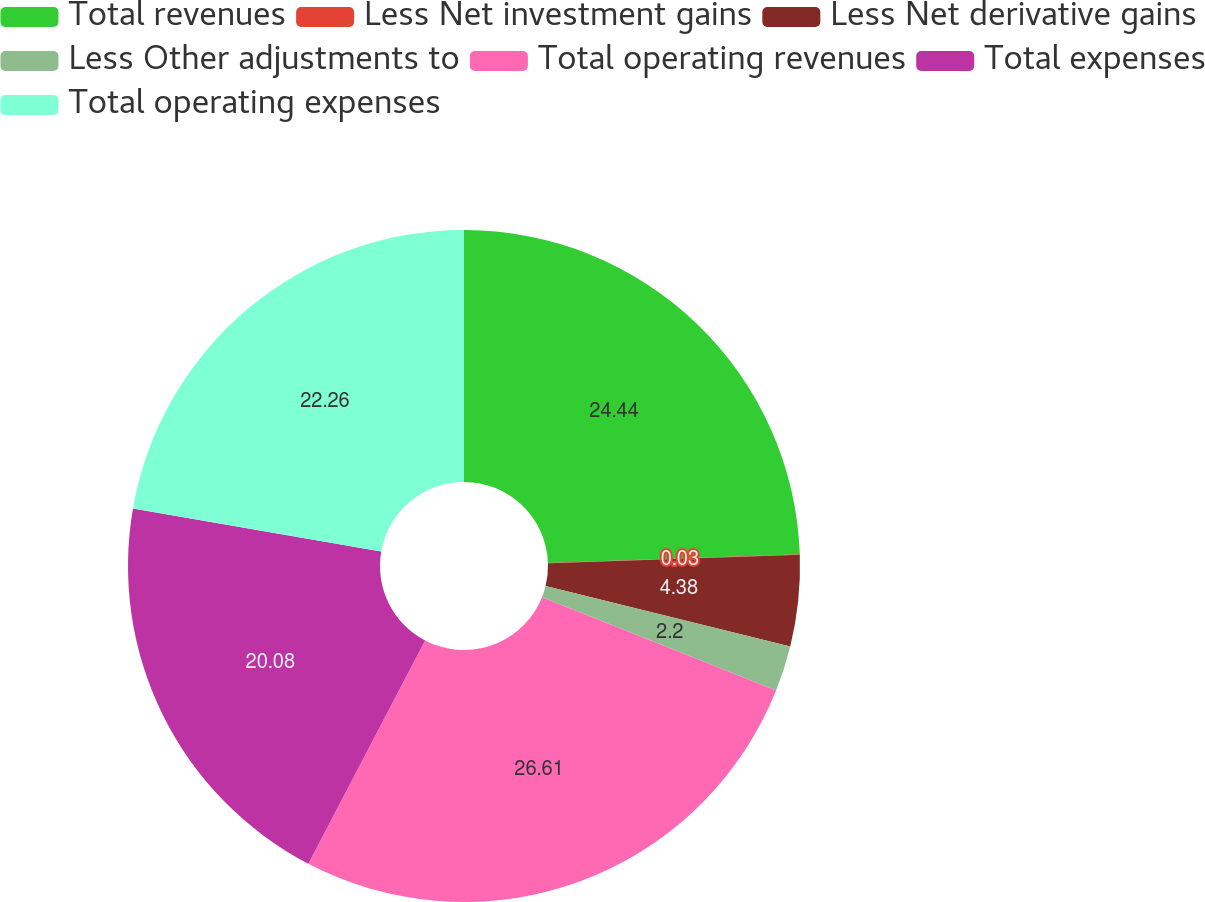<chart> <loc_0><loc_0><loc_500><loc_500><pie_chart><fcel>Total revenues<fcel>Less Net investment gains<fcel>Less Net derivative gains<fcel>Less Other adjustments to<fcel>Total operating revenues<fcel>Total expenses<fcel>Total operating expenses<nl><fcel>24.44%<fcel>0.03%<fcel>4.38%<fcel>2.2%<fcel>26.62%<fcel>20.08%<fcel>22.26%<nl></chart> 